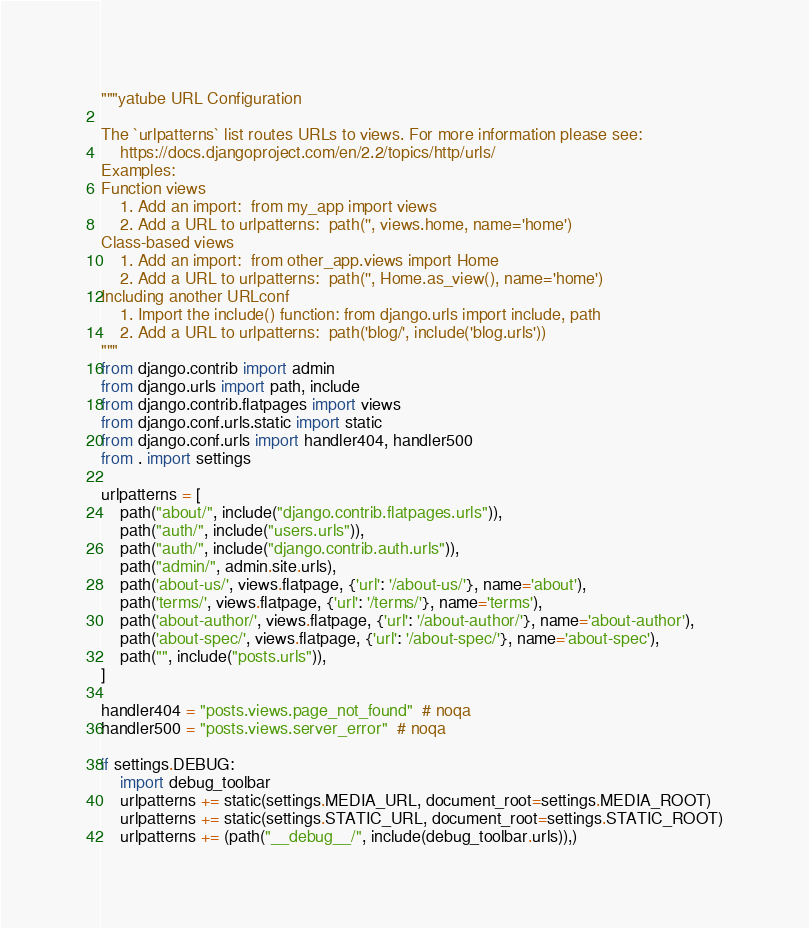Convert code to text. <code><loc_0><loc_0><loc_500><loc_500><_Python_>"""yatube URL Configuration

The `urlpatterns` list routes URLs to views. For more information please see:
    https://docs.djangoproject.com/en/2.2/topics/http/urls/
Examples:
Function views
    1. Add an import:  from my_app import views
    2. Add a URL to urlpatterns:  path('', views.home, name='home')
Class-based views
    1. Add an import:  from other_app.views import Home
    2. Add a URL to urlpatterns:  path('', Home.as_view(), name='home')
Including another URLconf
    1. Import the include() function: from django.urls import include, path
    2. Add a URL to urlpatterns:  path('blog/', include('blog.urls'))
"""
from django.contrib import admin
from django.urls import path, include
from django.contrib.flatpages import views
from django.conf.urls.static import static
from django.conf.urls import handler404, handler500
from . import settings

urlpatterns = [
    path("about/", include("django.contrib.flatpages.urls")),
    path("auth/", include("users.urls")),
    path("auth/", include("django.contrib.auth.urls")),
    path("admin/", admin.site.urls),
    path('about-us/', views.flatpage, {'url': '/about-us/'}, name='about'),
    path('terms/', views.flatpage, {'url': '/terms/'}, name='terms'),
    path('about-author/', views.flatpage, {'url': '/about-author/'}, name='about-author'),
    path('about-spec/', views.flatpage, {'url': '/about-spec/'}, name='about-spec'),
    path("", include("posts.urls")),
]

handler404 = "posts.views.page_not_found"  # noqa
handler500 = "posts.views.server_error"  # noqa

if settings.DEBUG:
    import debug_toolbar
    urlpatterns += static(settings.MEDIA_URL, document_root=settings.MEDIA_ROOT)
    urlpatterns += static(settings.STATIC_URL, document_root=settings.STATIC_ROOT)
    urlpatterns += (path("__debug__/", include(debug_toolbar.urls)),)
</code> 